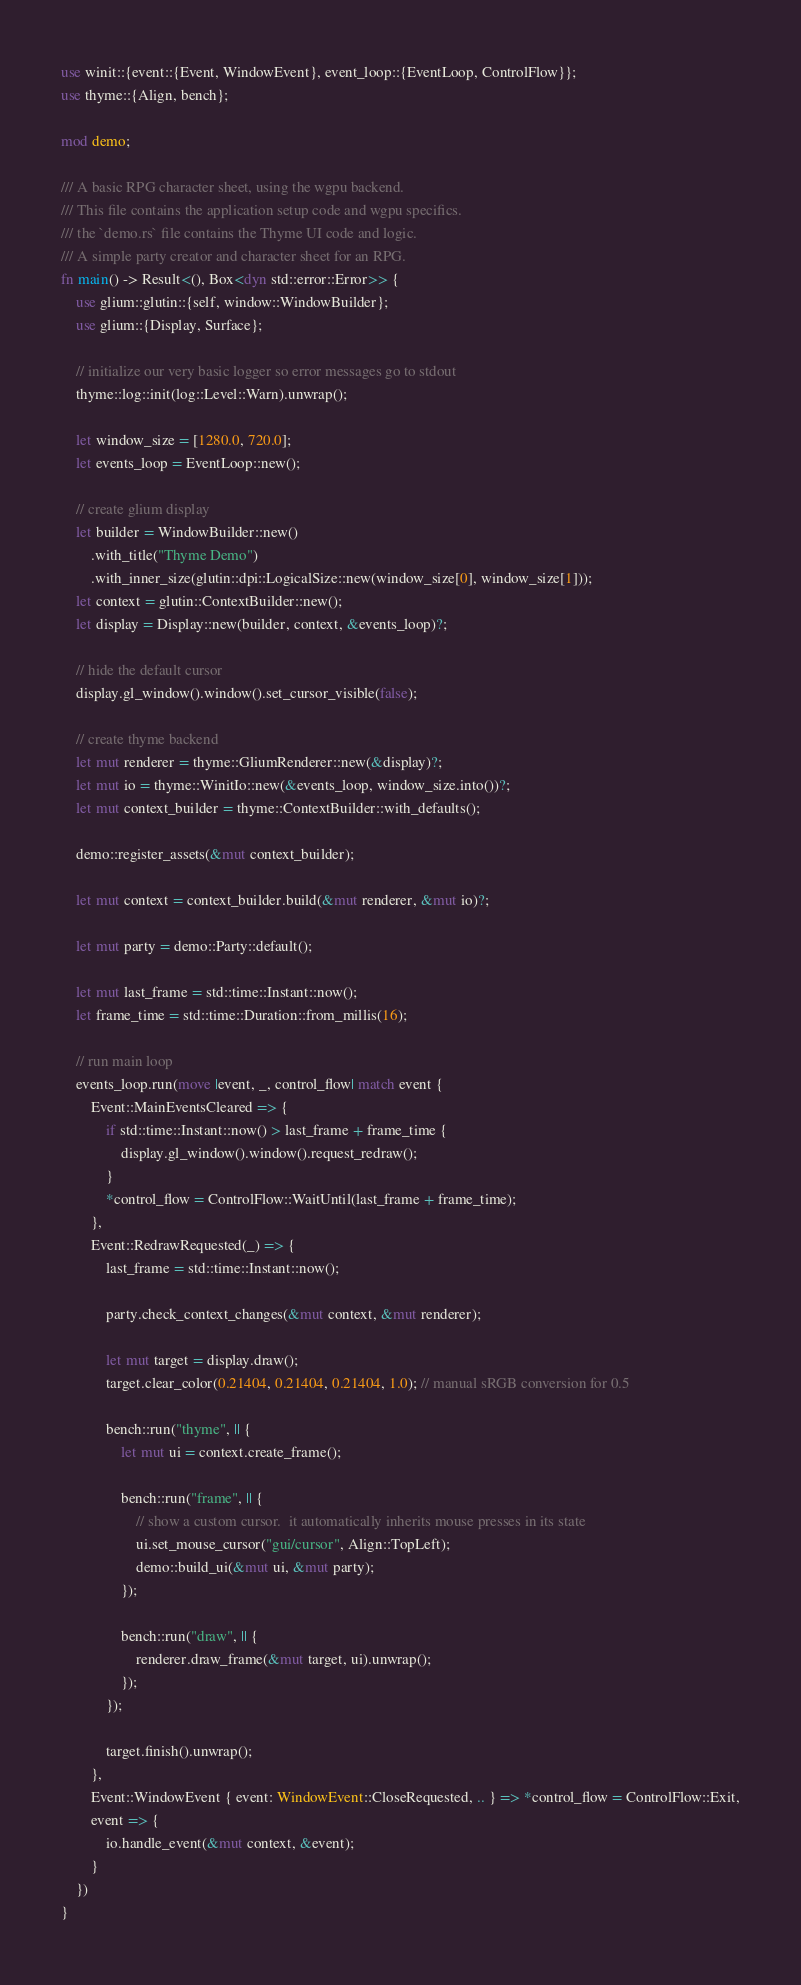Convert code to text. <code><loc_0><loc_0><loc_500><loc_500><_Rust_>use winit::{event::{Event, WindowEvent}, event_loop::{EventLoop, ControlFlow}};
use thyme::{Align, bench};

mod demo;

/// A basic RPG character sheet, using the wgpu backend.
/// This file contains the application setup code and wgpu specifics.
/// the `demo.rs` file contains the Thyme UI code and logic.
/// A simple party creator and character sheet for an RPG.
fn main() -> Result<(), Box<dyn std::error::Error>> {
    use glium::glutin::{self, window::WindowBuilder};
    use glium::{Display, Surface};

    // initialize our very basic logger so error messages go to stdout
    thyme::log::init(log::Level::Warn).unwrap();

    let window_size = [1280.0, 720.0];
    let events_loop = EventLoop::new();

    // create glium display
    let builder = WindowBuilder::new()
        .with_title("Thyme Demo")
        .with_inner_size(glutin::dpi::LogicalSize::new(window_size[0], window_size[1]));
    let context = glutin::ContextBuilder::new();
    let display = Display::new(builder, context, &events_loop)?;

    // hide the default cursor
    display.gl_window().window().set_cursor_visible(false);

    // create thyme backend
    let mut renderer = thyme::GliumRenderer::new(&display)?;
    let mut io = thyme::WinitIo::new(&events_loop, window_size.into())?;
    let mut context_builder = thyme::ContextBuilder::with_defaults();

    demo::register_assets(&mut context_builder);

    let mut context = context_builder.build(&mut renderer, &mut io)?;

    let mut party = demo::Party::default();

    let mut last_frame = std::time::Instant::now();
    let frame_time = std::time::Duration::from_millis(16);
    
    // run main loop
    events_loop.run(move |event, _, control_flow| match event {
        Event::MainEventsCleared => {
            if std::time::Instant::now() > last_frame + frame_time {
                display.gl_window().window().request_redraw();
            }
            *control_flow = ControlFlow::WaitUntil(last_frame + frame_time);
        },
        Event::RedrawRequested(_) => {
            last_frame = std::time::Instant::now();

            party.check_context_changes(&mut context, &mut renderer);

            let mut target = display.draw();
            target.clear_color(0.21404, 0.21404, 0.21404, 1.0); // manual sRGB conversion for 0.5

            bench::run("thyme", || {
                let mut ui = context.create_frame();

                bench::run("frame", || {
                    // show a custom cursor.  it automatically inherits mouse presses in its state
                    ui.set_mouse_cursor("gui/cursor", Align::TopLeft);
                    demo::build_ui(&mut ui, &mut party);
                });

                bench::run("draw", || {
                    renderer.draw_frame(&mut target, ui).unwrap();
                });
            });

            target.finish().unwrap();
        },
        Event::WindowEvent { event: WindowEvent::CloseRequested, .. } => *control_flow = ControlFlow::Exit,
        event => {
            io.handle_event(&mut context, &event);
        }
    })
}
</code> 